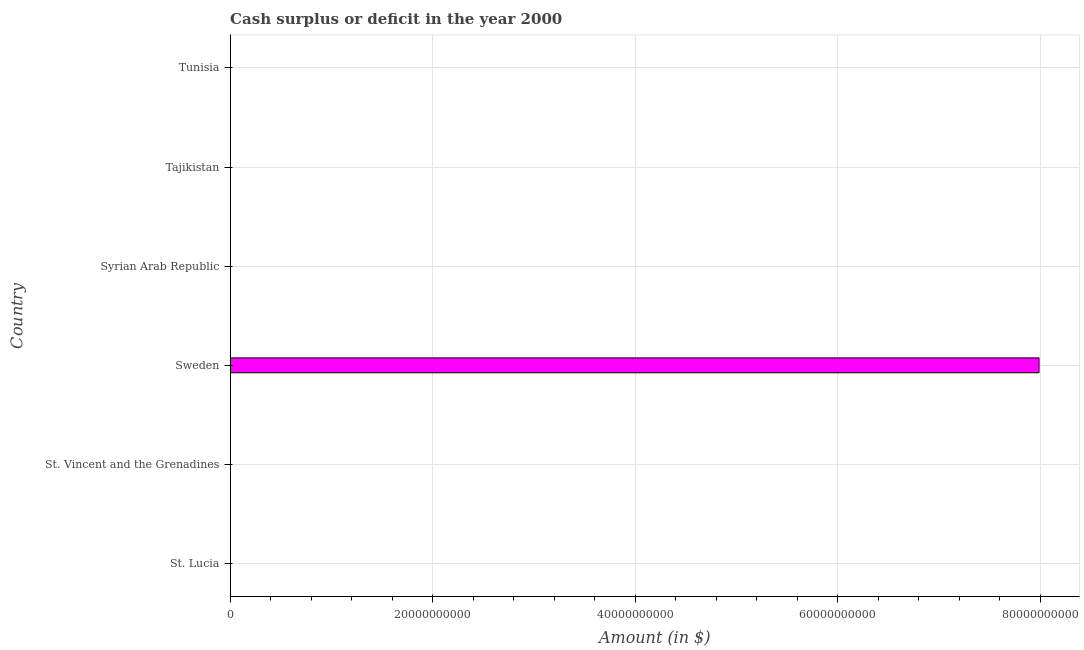Does the graph contain any zero values?
Your answer should be very brief. Yes. What is the title of the graph?
Offer a terse response. Cash surplus or deficit in the year 2000. What is the label or title of the X-axis?
Your answer should be very brief. Amount (in $). What is the label or title of the Y-axis?
Your answer should be compact. Country. What is the cash surplus or deficit in Tunisia?
Your answer should be very brief. 0. Across all countries, what is the maximum cash surplus or deficit?
Ensure brevity in your answer.  7.99e+1. In which country was the cash surplus or deficit maximum?
Provide a succinct answer. Sweden. What is the sum of the cash surplus or deficit?
Ensure brevity in your answer.  7.99e+1. What is the average cash surplus or deficit per country?
Your response must be concise. 1.33e+1. What is the median cash surplus or deficit?
Ensure brevity in your answer.  0. What is the difference between the highest and the lowest cash surplus or deficit?
Keep it short and to the point. 7.99e+1. How many bars are there?
Ensure brevity in your answer.  1. Are all the bars in the graph horizontal?
Give a very brief answer. Yes. What is the difference between two consecutive major ticks on the X-axis?
Offer a terse response. 2.00e+1. Are the values on the major ticks of X-axis written in scientific E-notation?
Your answer should be compact. No. What is the Amount (in $) of Sweden?
Your answer should be very brief. 7.99e+1. 